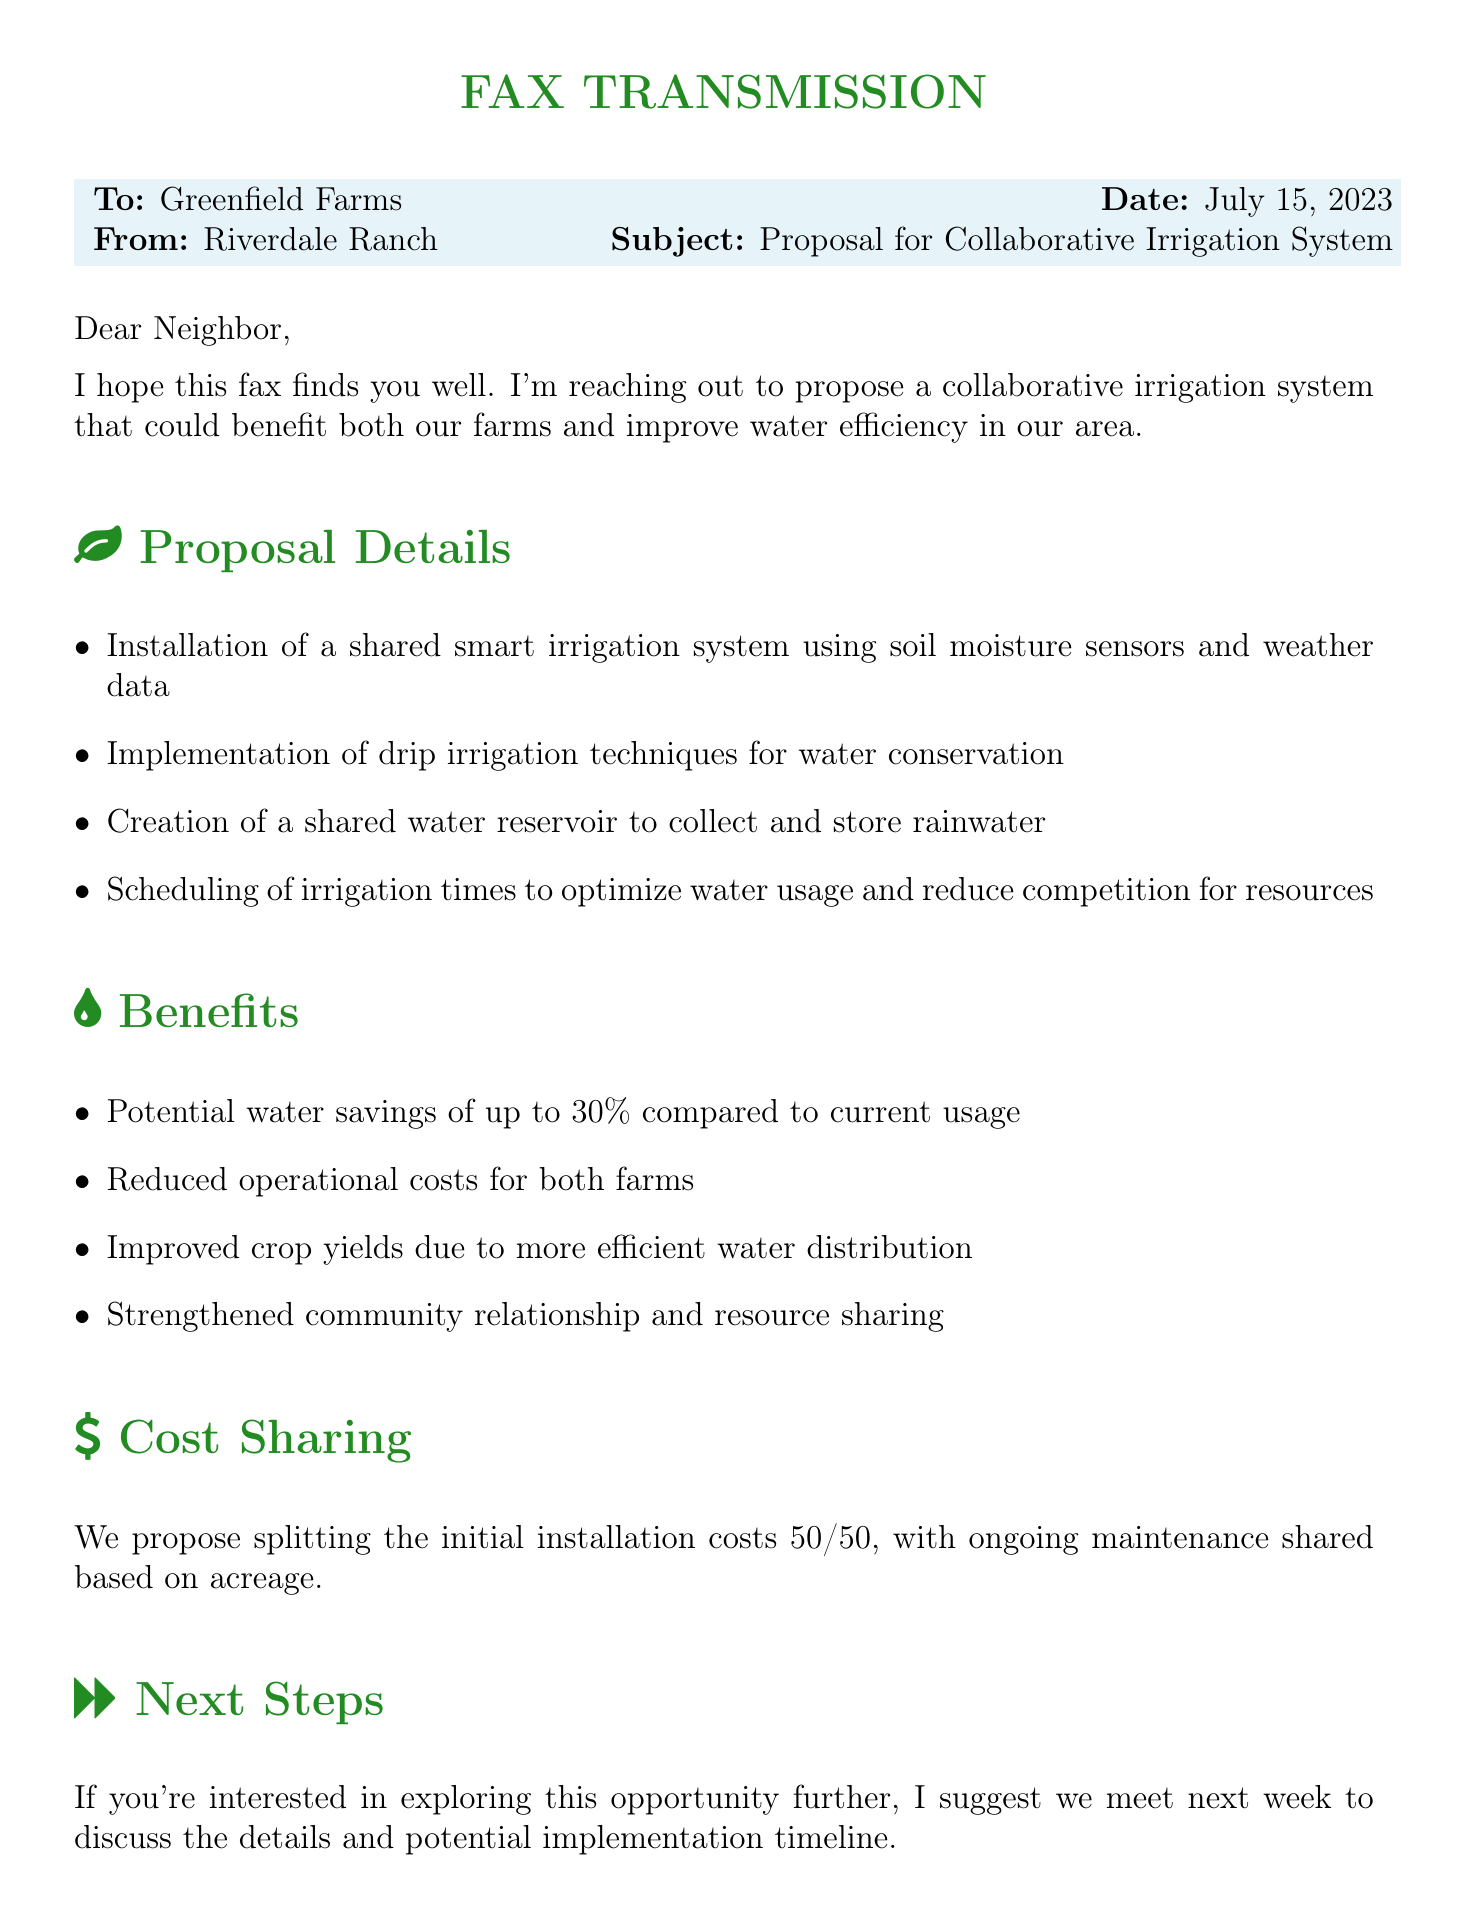What is the date of the fax? The date indicated in the fax is July 15, 2023.
Answer: July 15, 2023 Who is the sender of the fax? The fax is sent from Riverdale Ranch.
Answer: Riverdale Ranch What is the main purpose of the fax? The main purpose is a proposal for a collaborative irrigation system.
Answer: Proposal for Collaborative Irrigation System What is the proposed percentage of water savings? The document states potential water savings of up to 30%.
Answer: 30% How will costs be shared according to the proposal? The proposal suggests splitting the initial installation costs 50/50.
Answer: 50/50 What is one technique mentioned for water conservation? Drip irrigation techniques are mentioned as a method for water conservation.
Answer: Drip irrigation What is the next step suggested in the fax? The sender suggests meeting next week to discuss the details further.
Answer: Meet next week What type of irrigation system is proposed? A shared smart irrigation system is proposed in the document.
Answer: Shared smart irrigation system What is the sender's contact phone number? The contact phone number listed in the fax is (555) 123-4567.
Answer: (555) 123-4567 